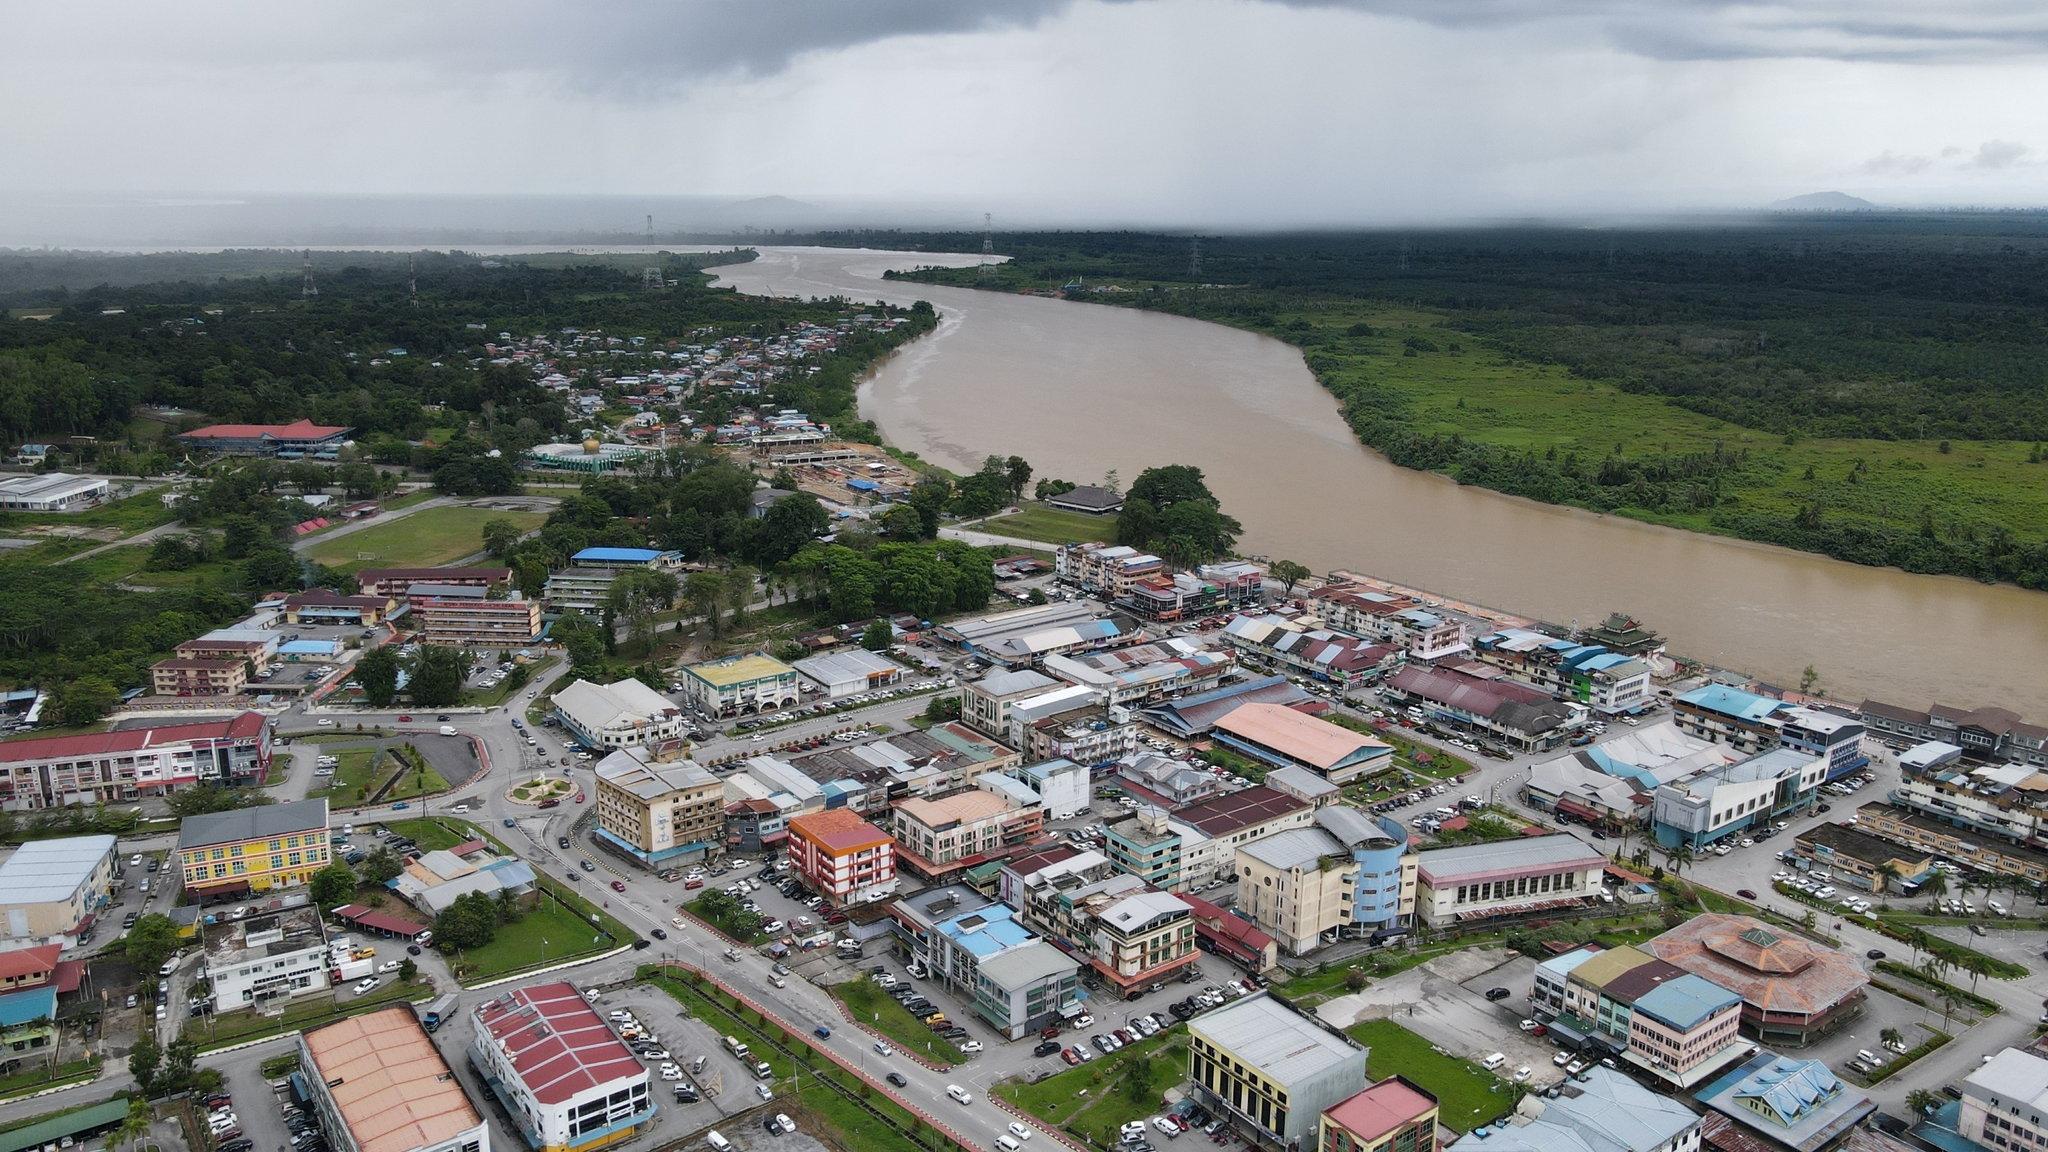If you could imagine an annual celebration in this town, what would it be like? The annual celebration, dubbed 'RiverFest,' is the highlight of the year for this town. The townspeople eagerly anticipate a week-long series of events that honor the river and their community's heritage. The festivities kick off with a grand opening ceremony featuring traditional music and dance performances that showcase the diverse cultural influences in the town. Each day of RiverFest includes parades with elaborately decorated floats that represent different neighborhoods, local businesses, and cultural organizations. There are boat races on the river that draw participants from near and far, with crowds cheering from the riverbanks. The town's streets are transformed into bustling marketplaces with stalls selling handmade crafts, local delicacies, and fresh produce. Workshops and exhibitions provide opportunities for residents to learn about the town’s history, environmental conservation, and arts and crafts. Evenings are reserved for live concerts, film screenings, and theatrical performances that celebrate local talent. The festival culminates in a spectacular fireworks display over the river, illuminating the night sky and leaving lasting memories for all who attend. RiverFest not only fosters a sense of unity and pride among the town's residents but also attracts visitors, boosting the local economy and strengthening community bonds. 